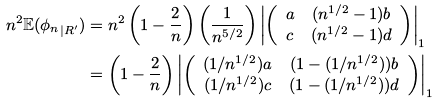<formula> <loc_0><loc_0><loc_500><loc_500>n ^ { 2 } \mathbb { E } ( { \phi _ { n } } _ { | R ^ { \prime } } ) & = n ^ { 2 } \left ( 1 - \frac { 2 } { n } \right ) \left ( \frac { 1 } { n ^ { 5 / 2 } } \right ) \left | \left ( \begin{array} { c c } a & ( n ^ { 1 / 2 } - 1 ) b \\ c & ( n ^ { 1 / 2 } - 1 ) d \end{array} \right ) \right | _ { 1 } \\ & = \left ( 1 - \frac { 2 } { n } \right ) \left | \left ( \begin{array} { c c } ( 1 / n ^ { 1 / 2 } ) a & ( 1 - ( 1 / n ^ { 1 / 2 } ) ) b \\ ( 1 / n ^ { 1 / 2 } ) c & ( 1 - ( 1 / n ^ { 1 / 2 } ) ) d \end{array} \right ) \right | _ { 1 }</formula> 